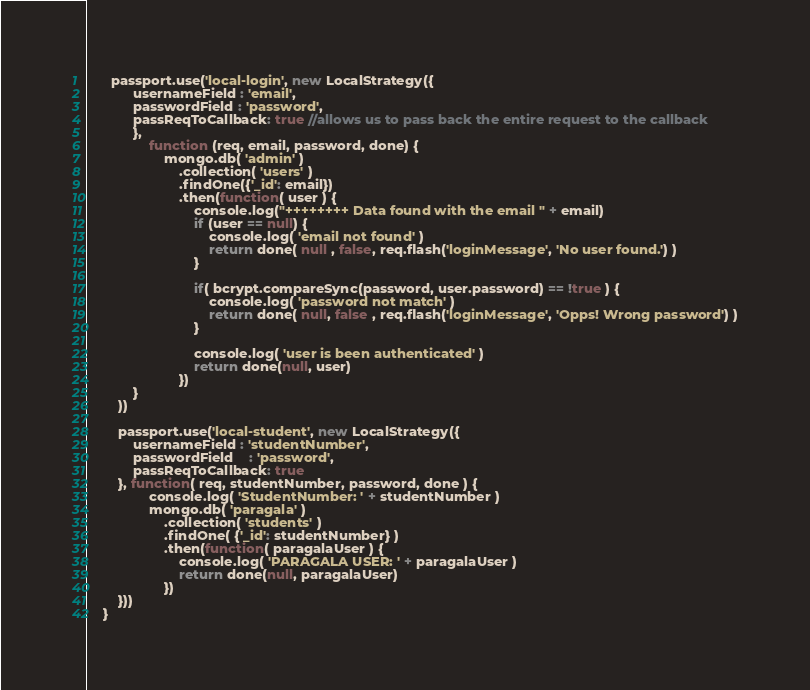Convert code to text. <code><loc_0><loc_0><loc_500><loc_500><_JavaScript_>	  passport.use('local-login', new LocalStrategy({
			usernameField : 'email',
			passwordField : 'password',
			passReqToCallback: true //allows us to pass back the entire request to the callback
			},
				function (req, email, password, done) {
					mongo.db( 'admin' )
						.collection( 'users' )
						.findOne({'_id': email})
						.then(function( user ) {
							console.log("++++++++ Data found with the email " + email)
							if (user == null) {
								console.log( 'email not found' )
								return done( null , false, req.flash('loginMessage', 'No user found.') )
							}

							if( bcrypt.compareSync(password, user.password) == !true ) {
								console.log( 'password not match' )
								return done( null, false , req.flash('loginMessage', 'Opps! Wrong password') )
							}

							console.log( 'user is been authenticated' )
							return done(null, user)
						})
			}
		))

		passport.use('local-student', new LocalStrategy({
			usernameField : 'studentNumber',
			passwordField	: 'password',
			passReqToCallback: true
		}, function( req, studentNumber, password, done ) {
				console.log( 'StudentNumber: ' + studentNumber )
				mongo.db( 'paragala' )
					.collection( 'students' )
					.findOne( {'_id': studentNumber} )
					.then(function( paragalaUser ) {
						console.log( 'PARAGALA USER: ' + paragalaUser )
						return done(null, paragalaUser)
					})
		}))
	}
</code> 